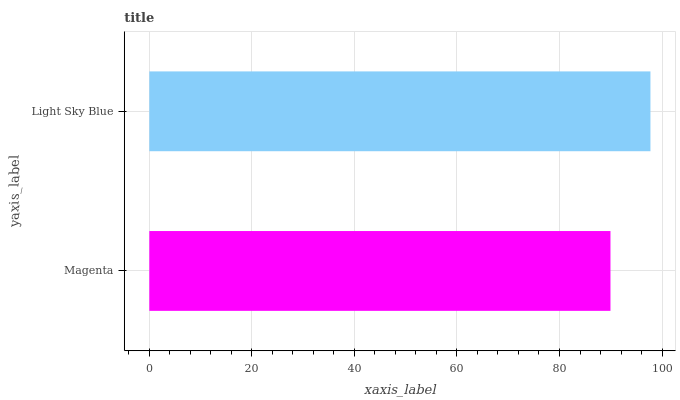Is Magenta the minimum?
Answer yes or no. Yes. Is Light Sky Blue the maximum?
Answer yes or no. Yes. Is Light Sky Blue the minimum?
Answer yes or no. No. Is Light Sky Blue greater than Magenta?
Answer yes or no. Yes. Is Magenta less than Light Sky Blue?
Answer yes or no. Yes. Is Magenta greater than Light Sky Blue?
Answer yes or no. No. Is Light Sky Blue less than Magenta?
Answer yes or no. No. Is Light Sky Blue the high median?
Answer yes or no. Yes. Is Magenta the low median?
Answer yes or no. Yes. Is Magenta the high median?
Answer yes or no. No. Is Light Sky Blue the low median?
Answer yes or no. No. 